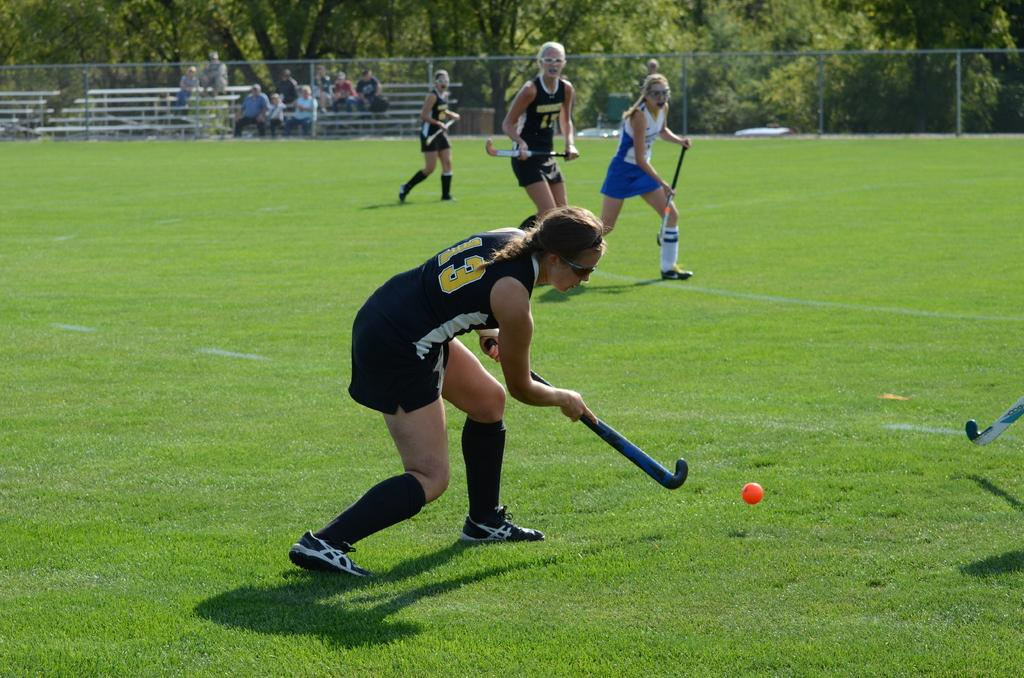What type of surface can be seen in the image? There is grass in the image. What activity are the people engaged in? People are playing hockey in the image. What object is used in the game? There is a ball in the image. Who is watching the game? There are audience members sitting and watching the game. What is separating the playing area from the surroundings? There is a fence in the image. What type of vegetation is visible in the image? Trees are present in the image. What type of loaf is being used to crush the sink in the image? There is no loaf or sink present in the image; it features people playing hockey on grass with a ball. 